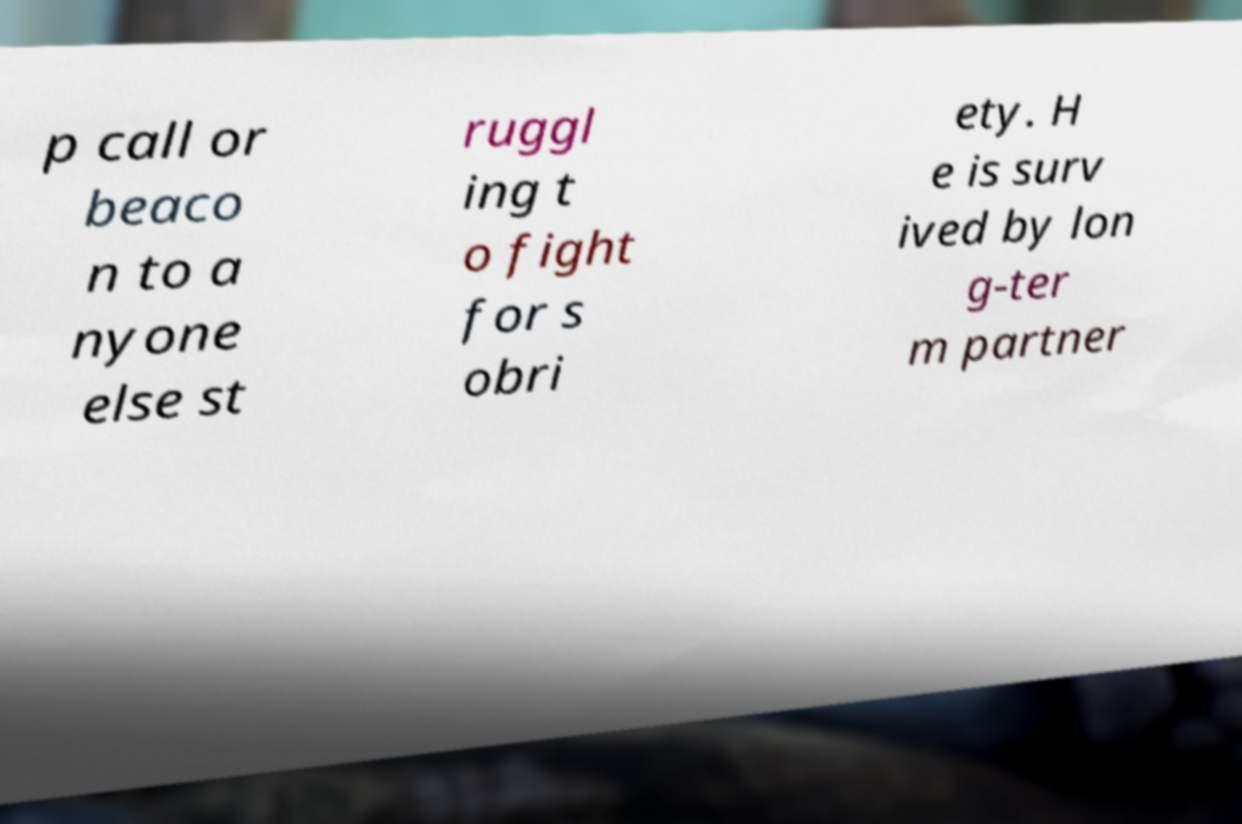Could you extract and type out the text from this image? p call or beaco n to a nyone else st ruggl ing t o fight for s obri ety. H e is surv ived by lon g-ter m partner 